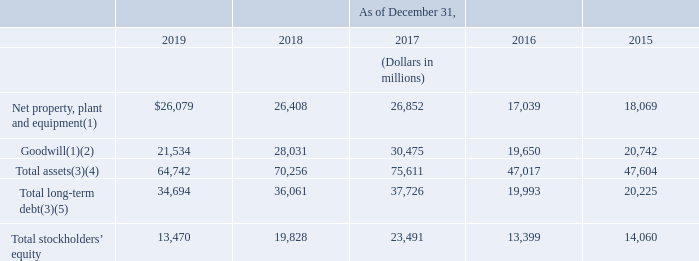Selected financial information from our consolidated balance sheets is as follows:
(1) During 2016, as a result of our then pending sale of a portion of our colocation business and data centers, we reclassified $1.1 billion in net property, plant and equipment and $1.1 billion of goodwill to assets held for sale which is included in other current assets on our consolidated balance sheet. See Note 3—Sale of Data Centers and Colocation Business to our consolidated financial statements in Item 8 of Part II of this report, for additional information.
(2) During 2019 and 2018, we recorded non-cash, non-tax-deductible goodwill impairment charges of $6.5 billion and $2.7 billion, respectively.
(3) In 2015, we adopted both ASU 2015-03 “Simplifying the Presentation of Debt Issuance Costs” and ASU 2015-17 “Balance Sheet Classification of Deferred Taxes” by retrospectively applying the requirements of the ASUs to our previously issued consolidated financial statements.
(4) In 2019, we adopted ASU 2016-02 “Leases (ASC 842)” by using the non-comparative transition option pursuant to ASU 2018-11. Therefore, we have not restated comparative period financial information for the effects of ASC 842.
(5) Total long-term debt includes current maturities of long-term debt and finance lease obligations of $305 million for the year ended December 31, 2016 associated with assets held for sale. For additional information on our total long-term debt, see Note 7— Long-Term Debt and Credit Facilities to our consolidated financial statements in Item 8 of Part II of this report. For total contractual obligations, see “Management’s Discussion and Analysis of Financial Condition and Results of Operations—Future Contractual Obligations” in Item 7 of Part II of this report.
What does total long-term debt include? Current maturities of long-term debt and finance lease obligations of $305 million for the year ended december 31, 2016 associated with assets held for sale. Regarding the total assets, what was adopted in 2019? Asu 2016-02 “leases (asc 842)” by using the non-comparative transition option pursuant to asu 2018-11. Which items were reclassified to assets held for sale in 2016? Net property, plant and equipment, goodwill. How many years was the total stockholders' equity above $14,000 million? 2018##2017##2015
Answer: 3. What is the change in goodwill from 2016 to 2017?
Answer scale should be: million. 30,475-19,650
Answer: 10825. What is the average amount of goodwill for 2016 and 2017?
Answer scale should be: million. (30,475+19,650)/2
Answer: 25062.5. 